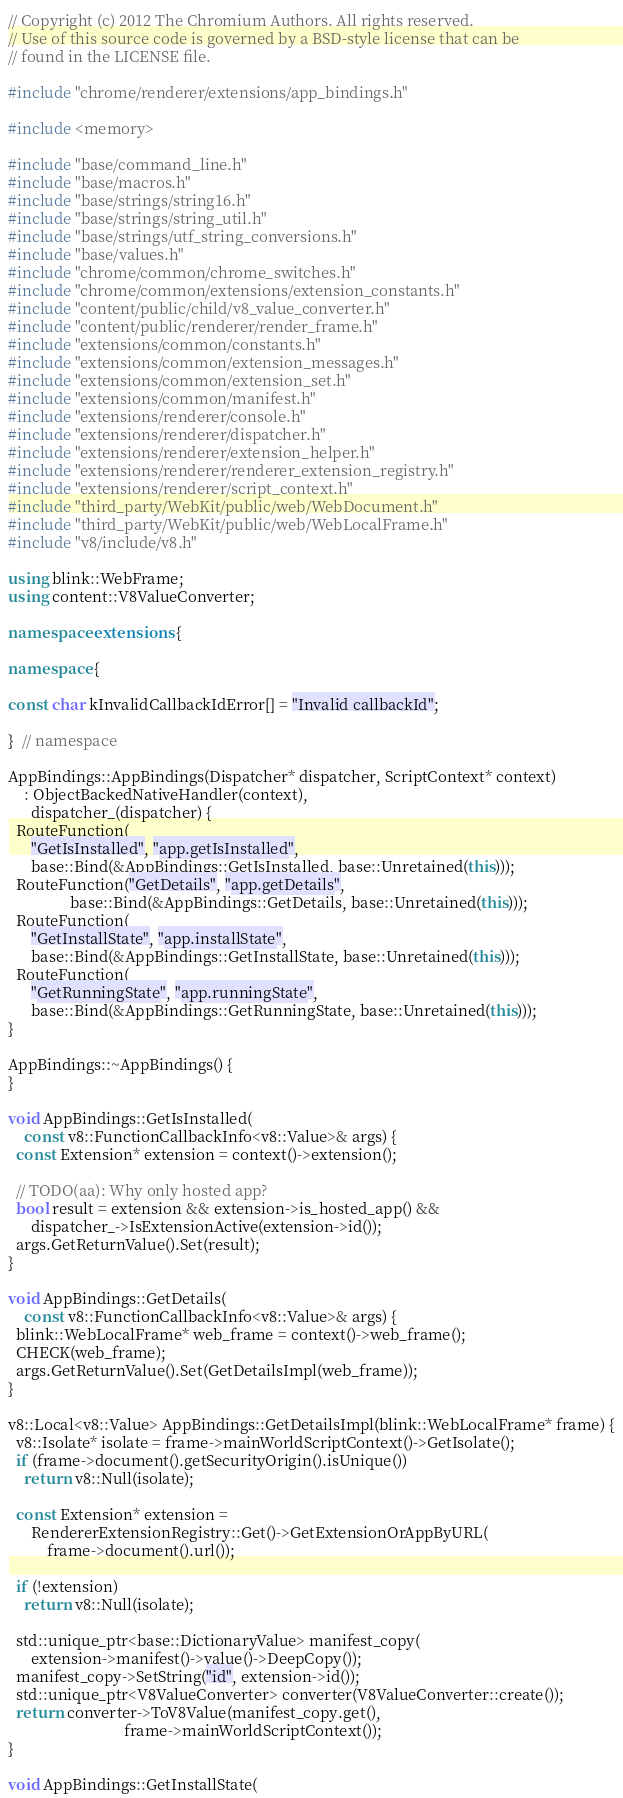<code> <loc_0><loc_0><loc_500><loc_500><_C++_>// Copyright (c) 2012 The Chromium Authors. All rights reserved.
// Use of this source code is governed by a BSD-style license that can be
// found in the LICENSE file.

#include "chrome/renderer/extensions/app_bindings.h"

#include <memory>

#include "base/command_line.h"
#include "base/macros.h"
#include "base/strings/string16.h"
#include "base/strings/string_util.h"
#include "base/strings/utf_string_conversions.h"
#include "base/values.h"
#include "chrome/common/chrome_switches.h"
#include "chrome/common/extensions/extension_constants.h"
#include "content/public/child/v8_value_converter.h"
#include "content/public/renderer/render_frame.h"
#include "extensions/common/constants.h"
#include "extensions/common/extension_messages.h"
#include "extensions/common/extension_set.h"
#include "extensions/common/manifest.h"
#include "extensions/renderer/console.h"
#include "extensions/renderer/dispatcher.h"
#include "extensions/renderer/extension_helper.h"
#include "extensions/renderer/renderer_extension_registry.h"
#include "extensions/renderer/script_context.h"
#include "third_party/WebKit/public/web/WebDocument.h"
#include "third_party/WebKit/public/web/WebLocalFrame.h"
#include "v8/include/v8.h"

using blink::WebFrame;
using content::V8ValueConverter;

namespace extensions {

namespace {

const char kInvalidCallbackIdError[] = "Invalid callbackId";

}  // namespace

AppBindings::AppBindings(Dispatcher* dispatcher, ScriptContext* context)
    : ObjectBackedNativeHandler(context),
      dispatcher_(dispatcher) {
  RouteFunction(
      "GetIsInstalled", "app.getIsInstalled",
      base::Bind(&AppBindings::GetIsInstalled, base::Unretained(this)));
  RouteFunction("GetDetails", "app.getDetails",
                base::Bind(&AppBindings::GetDetails, base::Unretained(this)));
  RouteFunction(
      "GetInstallState", "app.installState",
      base::Bind(&AppBindings::GetInstallState, base::Unretained(this)));
  RouteFunction(
      "GetRunningState", "app.runningState",
      base::Bind(&AppBindings::GetRunningState, base::Unretained(this)));
}

AppBindings::~AppBindings() {
}

void AppBindings::GetIsInstalled(
    const v8::FunctionCallbackInfo<v8::Value>& args) {
  const Extension* extension = context()->extension();

  // TODO(aa): Why only hosted app?
  bool result = extension && extension->is_hosted_app() &&
      dispatcher_->IsExtensionActive(extension->id());
  args.GetReturnValue().Set(result);
}

void AppBindings::GetDetails(
    const v8::FunctionCallbackInfo<v8::Value>& args) {
  blink::WebLocalFrame* web_frame = context()->web_frame();
  CHECK(web_frame);
  args.GetReturnValue().Set(GetDetailsImpl(web_frame));
}

v8::Local<v8::Value> AppBindings::GetDetailsImpl(blink::WebLocalFrame* frame) {
  v8::Isolate* isolate = frame->mainWorldScriptContext()->GetIsolate();
  if (frame->document().getSecurityOrigin().isUnique())
    return v8::Null(isolate);

  const Extension* extension =
      RendererExtensionRegistry::Get()->GetExtensionOrAppByURL(
          frame->document().url());

  if (!extension)
    return v8::Null(isolate);

  std::unique_ptr<base::DictionaryValue> manifest_copy(
      extension->manifest()->value()->DeepCopy());
  manifest_copy->SetString("id", extension->id());
  std::unique_ptr<V8ValueConverter> converter(V8ValueConverter::create());
  return converter->ToV8Value(manifest_copy.get(),
                              frame->mainWorldScriptContext());
}

void AppBindings::GetInstallState(</code> 